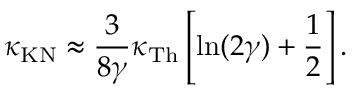Convert formula to latex. <formula><loc_0><loc_0><loc_500><loc_500>\kappa _ { K N } \approx \frac { 3 } { 8 \gamma } \kappa _ { T h } \left [ \ln ( 2 \gamma ) + \frac { 1 } { 2 } \right ] .</formula> 